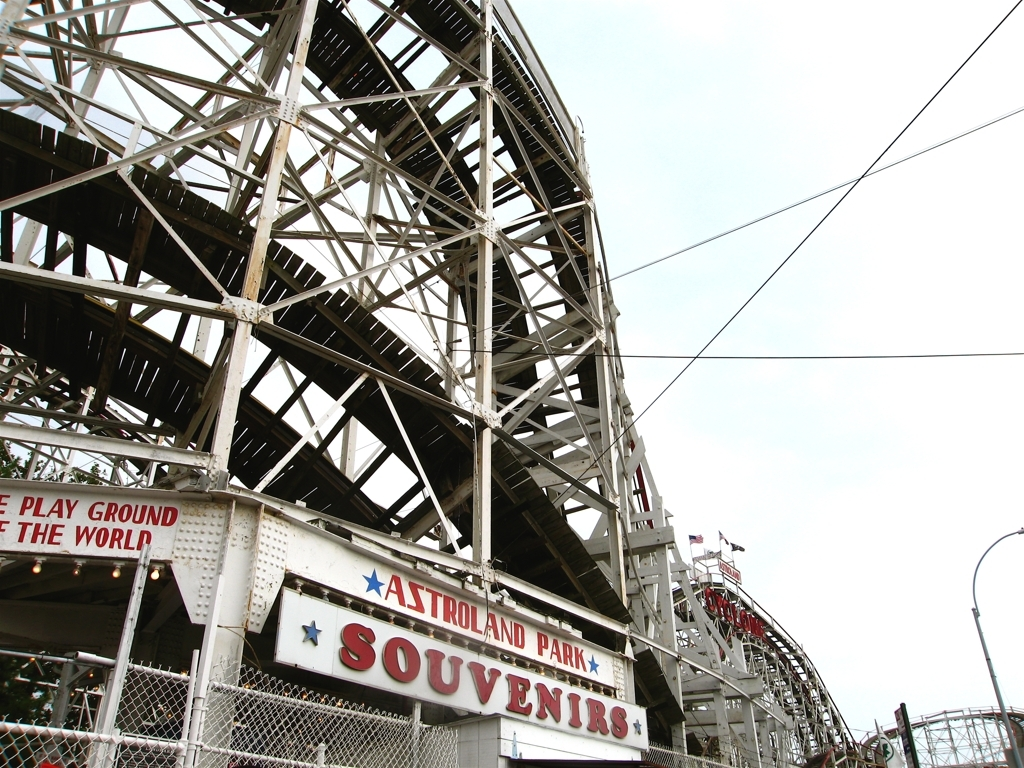How would you describe the focus of the image? The focus of the image is on the intricate structure of a large, wooden roller coaster, highlighting the complexity of its interwoven beams and supports. Below, there is signage for 'Astroland Park,' which hints at the image being taken at an amusement park, likely showcasing one of its main attractions. 